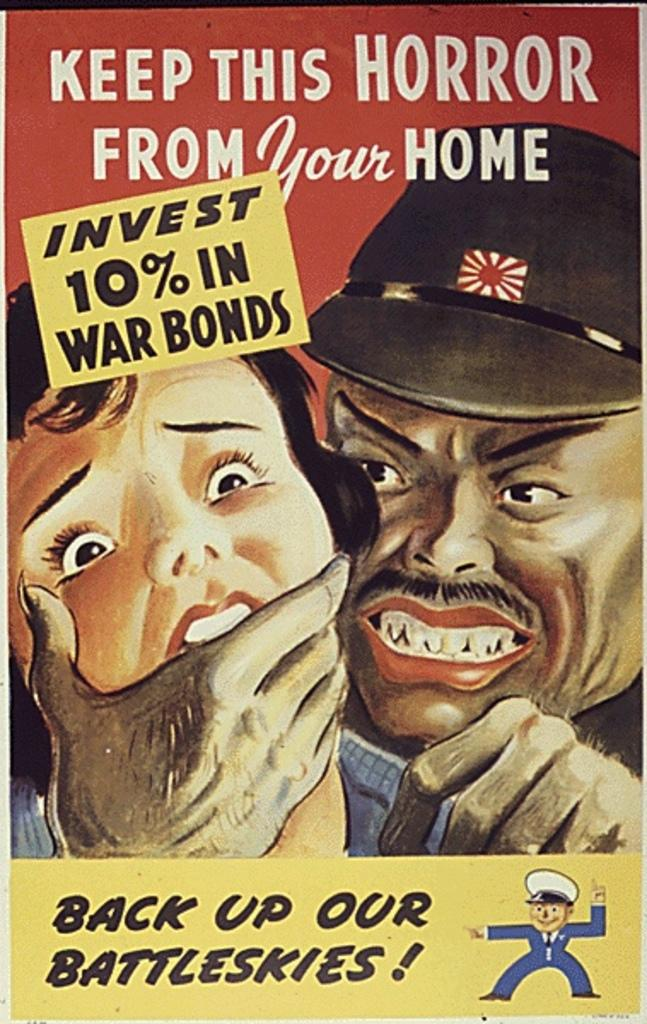What type of visual is depicted in the image? The image is a poster. Who are the people featured in the poster? There is a man and a girl in the poster. What else can be seen in the poster besides the people? There is some text in the poster. Can you see any hills in the background of the poster? There are no hills visible in the poster; it only features a man, a girl, and some text. What type of legal advice is the man in the poster providing? There is no indication in the poster that the man is providing legal advice or functioning as a lawyer. 